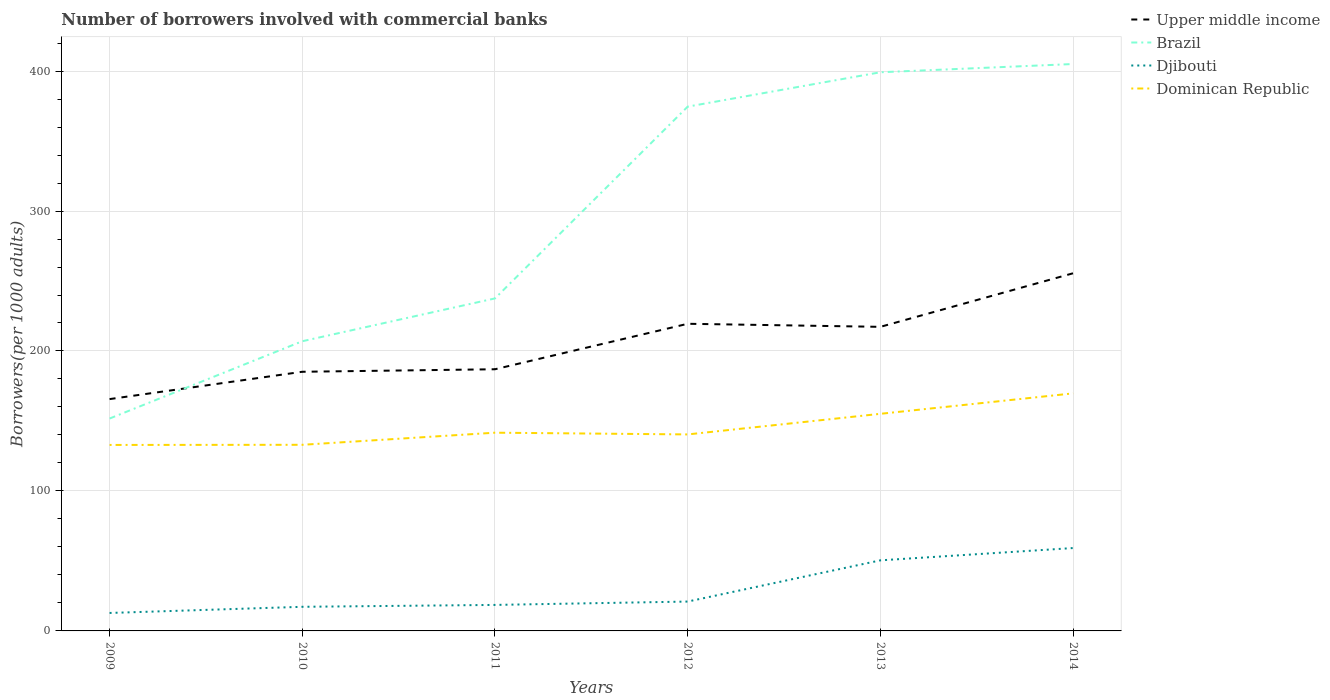How many different coloured lines are there?
Provide a succinct answer. 4. Does the line corresponding to Upper middle income intersect with the line corresponding to Dominican Republic?
Provide a succinct answer. No. Is the number of lines equal to the number of legend labels?
Offer a very short reply. Yes. Across all years, what is the maximum number of borrowers involved with commercial banks in Brazil?
Your answer should be compact. 151.74. What is the total number of borrowers involved with commercial banks in Djibouti in the graph?
Provide a short and direct response. -40.64. What is the difference between the highest and the second highest number of borrowers involved with commercial banks in Djibouti?
Provide a short and direct response. 46.39. What is the difference between the highest and the lowest number of borrowers involved with commercial banks in Djibouti?
Offer a very short reply. 2. Are the values on the major ticks of Y-axis written in scientific E-notation?
Your answer should be very brief. No. Does the graph contain any zero values?
Ensure brevity in your answer.  No. How many legend labels are there?
Ensure brevity in your answer.  4. How are the legend labels stacked?
Your answer should be compact. Vertical. What is the title of the graph?
Your response must be concise. Number of borrowers involved with commercial banks. Does "China" appear as one of the legend labels in the graph?
Provide a short and direct response. No. What is the label or title of the Y-axis?
Your answer should be compact. Borrowers(per 1000 adults). What is the Borrowers(per 1000 adults) of Upper middle income in 2009?
Make the answer very short. 165.63. What is the Borrowers(per 1000 adults) in Brazil in 2009?
Your answer should be very brief. 151.74. What is the Borrowers(per 1000 adults) in Djibouti in 2009?
Ensure brevity in your answer.  12.83. What is the Borrowers(per 1000 adults) of Dominican Republic in 2009?
Ensure brevity in your answer.  132.88. What is the Borrowers(per 1000 adults) of Upper middle income in 2010?
Provide a short and direct response. 185.15. What is the Borrowers(per 1000 adults) in Brazil in 2010?
Keep it short and to the point. 206.97. What is the Borrowers(per 1000 adults) in Djibouti in 2010?
Your answer should be very brief. 17.23. What is the Borrowers(per 1000 adults) in Dominican Republic in 2010?
Offer a very short reply. 132.98. What is the Borrowers(per 1000 adults) of Upper middle income in 2011?
Your answer should be compact. 186.95. What is the Borrowers(per 1000 adults) in Brazil in 2011?
Ensure brevity in your answer.  237.57. What is the Borrowers(per 1000 adults) in Djibouti in 2011?
Keep it short and to the point. 18.58. What is the Borrowers(per 1000 adults) of Dominican Republic in 2011?
Make the answer very short. 141.63. What is the Borrowers(per 1000 adults) of Upper middle income in 2012?
Your response must be concise. 219.44. What is the Borrowers(per 1000 adults) of Brazil in 2012?
Make the answer very short. 374.59. What is the Borrowers(per 1000 adults) of Djibouti in 2012?
Your answer should be compact. 20.98. What is the Borrowers(per 1000 adults) in Dominican Republic in 2012?
Your answer should be very brief. 140.39. What is the Borrowers(per 1000 adults) of Upper middle income in 2013?
Make the answer very short. 217.26. What is the Borrowers(per 1000 adults) in Brazil in 2013?
Offer a very short reply. 399.14. What is the Borrowers(per 1000 adults) of Djibouti in 2013?
Your answer should be compact. 50.43. What is the Borrowers(per 1000 adults) in Dominican Republic in 2013?
Ensure brevity in your answer.  155.11. What is the Borrowers(per 1000 adults) of Upper middle income in 2014?
Your response must be concise. 255.53. What is the Borrowers(per 1000 adults) in Brazil in 2014?
Make the answer very short. 405.03. What is the Borrowers(per 1000 adults) in Djibouti in 2014?
Your answer should be very brief. 59.22. What is the Borrowers(per 1000 adults) in Dominican Republic in 2014?
Offer a terse response. 169.72. Across all years, what is the maximum Borrowers(per 1000 adults) in Upper middle income?
Your answer should be very brief. 255.53. Across all years, what is the maximum Borrowers(per 1000 adults) of Brazil?
Your answer should be compact. 405.03. Across all years, what is the maximum Borrowers(per 1000 adults) of Djibouti?
Make the answer very short. 59.22. Across all years, what is the maximum Borrowers(per 1000 adults) in Dominican Republic?
Your response must be concise. 169.72. Across all years, what is the minimum Borrowers(per 1000 adults) of Upper middle income?
Offer a very short reply. 165.63. Across all years, what is the minimum Borrowers(per 1000 adults) in Brazil?
Offer a very short reply. 151.74. Across all years, what is the minimum Borrowers(per 1000 adults) of Djibouti?
Your answer should be compact. 12.83. Across all years, what is the minimum Borrowers(per 1000 adults) of Dominican Republic?
Provide a short and direct response. 132.88. What is the total Borrowers(per 1000 adults) in Upper middle income in the graph?
Make the answer very short. 1229.96. What is the total Borrowers(per 1000 adults) in Brazil in the graph?
Offer a terse response. 1775.05. What is the total Borrowers(per 1000 adults) in Djibouti in the graph?
Your response must be concise. 179.27. What is the total Borrowers(per 1000 adults) in Dominican Republic in the graph?
Make the answer very short. 872.71. What is the difference between the Borrowers(per 1000 adults) of Upper middle income in 2009 and that in 2010?
Provide a short and direct response. -19.53. What is the difference between the Borrowers(per 1000 adults) of Brazil in 2009 and that in 2010?
Your answer should be compact. -55.23. What is the difference between the Borrowers(per 1000 adults) of Djibouti in 2009 and that in 2010?
Keep it short and to the point. -4.4. What is the difference between the Borrowers(per 1000 adults) in Dominican Republic in 2009 and that in 2010?
Give a very brief answer. -0.1. What is the difference between the Borrowers(per 1000 adults) in Upper middle income in 2009 and that in 2011?
Ensure brevity in your answer.  -21.33. What is the difference between the Borrowers(per 1000 adults) in Brazil in 2009 and that in 2011?
Give a very brief answer. -85.83. What is the difference between the Borrowers(per 1000 adults) of Djibouti in 2009 and that in 2011?
Keep it short and to the point. -5.75. What is the difference between the Borrowers(per 1000 adults) of Dominican Republic in 2009 and that in 2011?
Provide a succinct answer. -8.75. What is the difference between the Borrowers(per 1000 adults) in Upper middle income in 2009 and that in 2012?
Keep it short and to the point. -53.81. What is the difference between the Borrowers(per 1000 adults) in Brazil in 2009 and that in 2012?
Provide a succinct answer. -222.85. What is the difference between the Borrowers(per 1000 adults) in Djibouti in 2009 and that in 2012?
Ensure brevity in your answer.  -8.15. What is the difference between the Borrowers(per 1000 adults) in Dominican Republic in 2009 and that in 2012?
Ensure brevity in your answer.  -7.51. What is the difference between the Borrowers(per 1000 adults) in Upper middle income in 2009 and that in 2013?
Provide a short and direct response. -51.63. What is the difference between the Borrowers(per 1000 adults) of Brazil in 2009 and that in 2013?
Offer a terse response. -247.4. What is the difference between the Borrowers(per 1000 adults) in Djibouti in 2009 and that in 2013?
Ensure brevity in your answer.  -37.59. What is the difference between the Borrowers(per 1000 adults) in Dominican Republic in 2009 and that in 2013?
Ensure brevity in your answer.  -22.24. What is the difference between the Borrowers(per 1000 adults) in Upper middle income in 2009 and that in 2014?
Your response must be concise. -89.9. What is the difference between the Borrowers(per 1000 adults) in Brazil in 2009 and that in 2014?
Ensure brevity in your answer.  -253.29. What is the difference between the Borrowers(per 1000 adults) of Djibouti in 2009 and that in 2014?
Your answer should be compact. -46.39. What is the difference between the Borrowers(per 1000 adults) of Dominican Republic in 2009 and that in 2014?
Your response must be concise. -36.85. What is the difference between the Borrowers(per 1000 adults) in Upper middle income in 2010 and that in 2011?
Keep it short and to the point. -1.8. What is the difference between the Borrowers(per 1000 adults) of Brazil in 2010 and that in 2011?
Ensure brevity in your answer.  -30.59. What is the difference between the Borrowers(per 1000 adults) of Djibouti in 2010 and that in 2011?
Your answer should be compact. -1.35. What is the difference between the Borrowers(per 1000 adults) of Dominican Republic in 2010 and that in 2011?
Provide a short and direct response. -8.65. What is the difference between the Borrowers(per 1000 adults) of Upper middle income in 2010 and that in 2012?
Provide a succinct answer. -34.28. What is the difference between the Borrowers(per 1000 adults) in Brazil in 2010 and that in 2012?
Provide a succinct answer. -167.62. What is the difference between the Borrowers(per 1000 adults) in Djibouti in 2010 and that in 2012?
Keep it short and to the point. -3.75. What is the difference between the Borrowers(per 1000 adults) of Dominican Republic in 2010 and that in 2012?
Provide a succinct answer. -7.41. What is the difference between the Borrowers(per 1000 adults) in Upper middle income in 2010 and that in 2013?
Your response must be concise. -32.1. What is the difference between the Borrowers(per 1000 adults) of Brazil in 2010 and that in 2013?
Keep it short and to the point. -192.17. What is the difference between the Borrowers(per 1000 adults) in Djibouti in 2010 and that in 2013?
Offer a very short reply. -33.19. What is the difference between the Borrowers(per 1000 adults) of Dominican Republic in 2010 and that in 2013?
Ensure brevity in your answer.  -22.14. What is the difference between the Borrowers(per 1000 adults) of Upper middle income in 2010 and that in 2014?
Keep it short and to the point. -70.38. What is the difference between the Borrowers(per 1000 adults) in Brazil in 2010 and that in 2014?
Ensure brevity in your answer.  -198.06. What is the difference between the Borrowers(per 1000 adults) in Djibouti in 2010 and that in 2014?
Keep it short and to the point. -41.99. What is the difference between the Borrowers(per 1000 adults) of Dominican Republic in 2010 and that in 2014?
Your response must be concise. -36.74. What is the difference between the Borrowers(per 1000 adults) of Upper middle income in 2011 and that in 2012?
Provide a succinct answer. -32.48. What is the difference between the Borrowers(per 1000 adults) of Brazil in 2011 and that in 2012?
Your answer should be very brief. -137.03. What is the difference between the Borrowers(per 1000 adults) of Djibouti in 2011 and that in 2012?
Ensure brevity in your answer.  -2.4. What is the difference between the Borrowers(per 1000 adults) of Dominican Republic in 2011 and that in 2012?
Your answer should be compact. 1.24. What is the difference between the Borrowers(per 1000 adults) in Upper middle income in 2011 and that in 2013?
Give a very brief answer. -30.3. What is the difference between the Borrowers(per 1000 adults) of Brazil in 2011 and that in 2013?
Ensure brevity in your answer.  -161.57. What is the difference between the Borrowers(per 1000 adults) of Djibouti in 2011 and that in 2013?
Provide a succinct answer. -31.85. What is the difference between the Borrowers(per 1000 adults) of Dominican Republic in 2011 and that in 2013?
Your answer should be very brief. -13.49. What is the difference between the Borrowers(per 1000 adults) of Upper middle income in 2011 and that in 2014?
Offer a terse response. -68.58. What is the difference between the Borrowers(per 1000 adults) in Brazil in 2011 and that in 2014?
Provide a short and direct response. -167.46. What is the difference between the Borrowers(per 1000 adults) of Djibouti in 2011 and that in 2014?
Give a very brief answer. -40.64. What is the difference between the Borrowers(per 1000 adults) in Dominican Republic in 2011 and that in 2014?
Provide a short and direct response. -28.09. What is the difference between the Borrowers(per 1000 adults) of Upper middle income in 2012 and that in 2013?
Provide a short and direct response. 2.18. What is the difference between the Borrowers(per 1000 adults) of Brazil in 2012 and that in 2013?
Keep it short and to the point. -24.55. What is the difference between the Borrowers(per 1000 adults) of Djibouti in 2012 and that in 2013?
Give a very brief answer. -29.45. What is the difference between the Borrowers(per 1000 adults) of Dominican Republic in 2012 and that in 2013?
Offer a terse response. -14.72. What is the difference between the Borrowers(per 1000 adults) of Upper middle income in 2012 and that in 2014?
Offer a very short reply. -36.09. What is the difference between the Borrowers(per 1000 adults) in Brazil in 2012 and that in 2014?
Offer a terse response. -30.44. What is the difference between the Borrowers(per 1000 adults) of Djibouti in 2012 and that in 2014?
Offer a very short reply. -38.24. What is the difference between the Borrowers(per 1000 adults) of Dominican Republic in 2012 and that in 2014?
Your answer should be very brief. -29.33. What is the difference between the Borrowers(per 1000 adults) of Upper middle income in 2013 and that in 2014?
Keep it short and to the point. -38.28. What is the difference between the Borrowers(per 1000 adults) in Brazil in 2013 and that in 2014?
Offer a terse response. -5.89. What is the difference between the Borrowers(per 1000 adults) of Djibouti in 2013 and that in 2014?
Keep it short and to the point. -8.79. What is the difference between the Borrowers(per 1000 adults) in Dominican Republic in 2013 and that in 2014?
Your answer should be very brief. -14.61. What is the difference between the Borrowers(per 1000 adults) in Upper middle income in 2009 and the Borrowers(per 1000 adults) in Brazil in 2010?
Offer a very short reply. -41.35. What is the difference between the Borrowers(per 1000 adults) of Upper middle income in 2009 and the Borrowers(per 1000 adults) of Djibouti in 2010?
Provide a succinct answer. 148.39. What is the difference between the Borrowers(per 1000 adults) in Upper middle income in 2009 and the Borrowers(per 1000 adults) in Dominican Republic in 2010?
Offer a very short reply. 32.65. What is the difference between the Borrowers(per 1000 adults) in Brazil in 2009 and the Borrowers(per 1000 adults) in Djibouti in 2010?
Keep it short and to the point. 134.51. What is the difference between the Borrowers(per 1000 adults) in Brazil in 2009 and the Borrowers(per 1000 adults) in Dominican Republic in 2010?
Give a very brief answer. 18.76. What is the difference between the Borrowers(per 1000 adults) in Djibouti in 2009 and the Borrowers(per 1000 adults) in Dominican Republic in 2010?
Your answer should be compact. -120.15. What is the difference between the Borrowers(per 1000 adults) in Upper middle income in 2009 and the Borrowers(per 1000 adults) in Brazil in 2011?
Provide a succinct answer. -71.94. What is the difference between the Borrowers(per 1000 adults) in Upper middle income in 2009 and the Borrowers(per 1000 adults) in Djibouti in 2011?
Make the answer very short. 147.05. What is the difference between the Borrowers(per 1000 adults) in Upper middle income in 2009 and the Borrowers(per 1000 adults) in Dominican Republic in 2011?
Ensure brevity in your answer.  24. What is the difference between the Borrowers(per 1000 adults) of Brazil in 2009 and the Borrowers(per 1000 adults) of Djibouti in 2011?
Your answer should be compact. 133.16. What is the difference between the Borrowers(per 1000 adults) in Brazil in 2009 and the Borrowers(per 1000 adults) in Dominican Republic in 2011?
Your response must be concise. 10.11. What is the difference between the Borrowers(per 1000 adults) of Djibouti in 2009 and the Borrowers(per 1000 adults) of Dominican Republic in 2011?
Make the answer very short. -128.8. What is the difference between the Borrowers(per 1000 adults) of Upper middle income in 2009 and the Borrowers(per 1000 adults) of Brazil in 2012?
Your answer should be very brief. -208.97. What is the difference between the Borrowers(per 1000 adults) in Upper middle income in 2009 and the Borrowers(per 1000 adults) in Djibouti in 2012?
Your answer should be compact. 144.65. What is the difference between the Borrowers(per 1000 adults) in Upper middle income in 2009 and the Borrowers(per 1000 adults) in Dominican Republic in 2012?
Provide a short and direct response. 25.24. What is the difference between the Borrowers(per 1000 adults) of Brazil in 2009 and the Borrowers(per 1000 adults) of Djibouti in 2012?
Your response must be concise. 130.76. What is the difference between the Borrowers(per 1000 adults) of Brazil in 2009 and the Borrowers(per 1000 adults) of Dominican Republic in 2012?
Ensure brevity in your answer.  11.35. What is the difference between the Borrowers(per 1000 adults) in Djibouti in 2009 and the Borrowers(per 1000 adults) in Dominican Republic in 2012?
Your answer should be very brief. -127.56. What is the difference between the Borrowers(per 1000 adults) in Upper middle income in 2009 and the Borrowers(per 1000 adults) in Brazil in 2013?
Your answer should be compact. -233.52. What is the difference between the Borrowers(per 1000 adults) of Upper middle income in 2009 and the Borrowers(per 1000 adults) of Djibouti in 2013?
Provide a short and direct response. 115.2. What is the difference between the Borrowers(per 1000 adults) in Upper middle income in 2009 and the Borrowers(per 1000 adults) in Dominican Republic in 2013?
Your answer should be compact. 10.51. What is the difference between the Borrowers(per 1000 adults) in Brazil in 2009 and the Borrowers(per 1000 adults) in Djibouti in 2013?
Your answer should be compact. 101.31. What is the difference between the Borrowers(per 1000 adults) in Brazil in 2009 and the Borrowers(per 1000 adults) in Dominican Republic in 2013?
Offer a terse response. -3.37. What is the difference between the Borrowers(per 1000 adults) in Djibouti in 2009 and the Borrowers(per 1000 adults) in Dominican Republic in 2013?
Your response must be concise. -142.28. What is the difference between the Borrowers(per 1000 adults) in Upper middle income in 2009 and the Borrowers(per 1000 adults) in Brazil in 2014?
Offer a very short reply. -239.4. What is the difference between the Borrowers(per 1000 adults) in Upper middle income in 2009 and the Borrowers(per 1000 adults) in Djibouti in 2014?
Make the answer very short. 106.41. What is the difference between the Borrowers(per 1000 adults) of Upper middle income in 2009 and the Borrowers(per 1000 adults) of Dominican Republic in 2014?
Your answer should be compact. -4.09. What is the difference between the Borrowers(per 1000 adults) of Brazil in 2009 and the Borrowers(per 1000 adults) of Djibouti in 2014?
Provide a succinct answer. 92.52. What is the difference between the Borrowers(per 1000 adults) of Brazil in 2009 and the Borrowers(per 1000 adults) of Dominican Republic in 2014?
Your response must be concise. -17.98. What is the difference between the Borrowers(per 1000 adults) of Djibouti in 2009 and the Borrowers(per 1000 adults) of Dominican Republic in 2014?
Give a very brief answer. -156.89. What is the difference between the Borrowers(per 1000 adults) in Upper middle income in 2010 and the Borrowers(per 1000 adults) in Brazil in 2011?
Make the answer very short. -52.42. What is the difference between the Borrowers(per 1000 adults) in Upper middle income in 2010 and the Borrowers(per 1000 adults) in Djibouti in 2011?
Offer a terse response. 166.57. What is the difference between the Borrowers(per 1000 adults) of Upper middle income in 2010 and the Borrowers(per 1000 adults) of Dominican Republic in 2011?
Make the answer very short. 43.52. What is the difference between the Borrowers(per 1000 adults) of Brazil in 2010 and the Borrowers(per 1000 adults) of Djibouti in 2011?
Your answer should be compact. 188.39. What is the difference between the Borrowers(per 1000 adults) in Brazil in 2010 and the Borrowers(per 1000 adults) in Dominican Republic in 2011?
Offer a terse response. 65.35. What is the difference between the Borrowers(per 1000 adults) of Djibouti in 2010 and the Borrowers(per 1000 adults) of Dominican Republic in 2011?
Give a very brief answer. -124.4. What is the difference between the Borrowers(per 1000 adults) of Upper middle income in 2010 and the Borrowers(per 1000 adults) of Brazil in 2012?
Offer a terse response. -189.44. What is the difference between the Borrowers(per 1000 adults) in Upper middle income in 2010 and the Borrowers(per 1000 adults) in Djibouti in 2012?
Ensure brevity in your answer.  164.17. What is the difference between the Borrowers(per 1000 adults) of Upper middle income in 2010 and the Borrowers(per 1000 adults) of Dominican Republic in 2012?
Ensure brevity in your answer.  44.76. What is the difference between the Borrowers(per 1000 adults) of Brazil in 2010 and the Borrowers(per 1000 adults) of Djibouti in 2012?
Offer a terse response. 186. What is the difference between the Borrowers(per 1000 adults) in Brazil in 2010 and the Borrowers(per 1000 adults) in Dominican Republic in 2012?
Offer a terse response. 66.58. What is the difference between the Borrowers(per 1000 adults) of Djibouti in 2010 and the Borrowers(per 1000 adults) of Dominican Republic in 2012?
Give a very brief answer. -123.16. What is the difference between the Borrowers(per 1000 adults) of Upper middle income in 2010 and the Borrowers(per 1000 adults) of Brazil in 2013?
Ensure brevity in your answer.  -213.99. What is the difference between the Borrowers(per 1000 adults) of Upper middle income in 2010 and the Borrowers(per 1000 adults) of Djibouti in 2013?
Give a very brief answer. 134.73. What is the difference between the Borrowers(per 1000 adults) of Upper middle income in 2010 and the Borrowers(per 1000 adults) of Dominican Republic in 2013?
Provide a succinct answer. 30.04. What is the difference between the Borrowers(per 1000 adults) of Brazil in 2010 and the Borrowers(per 1000 adults) of Djibouti in 2013?
Provide a short and direct response. 156.55. What is the difference between the Borrowers(per 1000 adults) in Brazil in 2010 and the Borrowers(per 1000 adults) in Dominican Republic in 2013?
Ensure brevity in your answer.  51.86. What is the difference between the Borrowers(per 1000 adults) in Djibouti in 2010 and the Borrowers(per 1000 adults) in Dominican Republic in 2013?
Your response must be concise. -137.88. What is the difference between the Borrowers(per 1000 adults) in Upper middle income in 2010 and the Borrowers(per 1000 adults) in Brazil in 2014?
Your answer should be very brief. -219.88. What is the difference between the Borrowers(per 1000 adults) in Upper middle income in 2010 and the Borrowers(per 1000 adults) in Djibouti in 2014?
Offer a very short reply. 125.93. What is the difference between the Borrowers(per 1000 adults) in Upper middle income in 2010 and the Borrowers(per 1000 adults) in Dominican Republic in 2014?
Offer a terse response. 15.43. What is the difference between the Borrowers(per 1000 adults) in Brazil in 2010 and the Borrowers(per 1000 adults) in Djibouti in 2014?
Your response must be concise. 147.75. What is the difference between the Borrowers(per 1000 adults) in Brazil in 2010 and the Borrowers(per 1000 adults) in Dominican Republic in 2014?
Keep it short and to the point. 37.25. What is the difference between the Borrowers(per 1000 adults) in Djibouti in 2010 and the Borrowers(per 1000 adults) in Dominican Republic in 2014?
Ensure brevity in your answer.  -152.49. What is the difference between the Borrowers(per 1000 adults) of Upper middle income in 2011 and the Borrowers(per 1000 adults) of Brazil in 2012?
Your answer should be compact. -187.64. What is the difference between the Borrowers(per 1000 adults) in Upper middle income in 2011 and the Borrowers(per 1000 adults) in Djibouti in 2012?
Provide a succinct answer. 165.98. What is the difference between the Borrowers(per 1000 adults) in Upper middle income in 2011 and the Borrowers(per 1000 adults) in Dominican Republic in 2012?
Offer a terse response. 46.56. What is the difference between the Borrowers(per 1000 adults) of Brazil in 2011 and the Borrowers(per 1000 adults) of Djibouti in 2012?
Give a very brief answer. 216.59. What is the difference between the Borrowers(per 1000 adults) of Brazil in 2011 and the Borrowers(per 1000 adults) of Dominican Republic in 2012?
Offer a terse response. 97.18. What is the difference between the Borrowers(per 1000 adults) in Djibouti in 2011 and the Borrowers(per 1000 adults) in Dominican Republic in 2012?
Ensure brevity in your answer.  -121.81. What is the difference between the Borrowers(per 1000 adults) of Upper middle income in 2011 and the Borrowers(per 1000 adults) of Brazil in 2013?
Offer a terse response. -212.19. What is the difference between the Borrowers(per 1000 adults) in Upper middle income in 2011 and the Borrowers(per 1000 adults) in Djibouti in 2013?
Offer a terse response. 136.53. What is the difference between the Borrowers(per 1000 adults) of Upper middle income in 2011 and the Borrowers(per 1000 adults) of Dominican Republic in 2013?
Offer a terse response. 31.84. What is the difference between the Borrowers(per 1000 adults) in Brazil in 2011 and the Borrowers(per 1000 adults) in Djibouti in 2013?
Provide a succinct answer. 187.14. What is the difference between the Borrowers(per 1000 adults) in Brazil in 2011 and the Borrowers(per 1000 adults) in Dominican Republic in 2013?
Provide a short and direct response. 82.45. What is the difference between the Borrowers(per 1000 adults) of Djibouti in 2011 and the Borrowers(per 1000 adults) of Dominican Republic in 2013?
Your response must be concise. -136.53. What is the difference between the Borrowers(per 1000 adults) in Upper middle income in 2011 and the Borrowers(per 1000 adults) in Brazil in 2014?
Your response must be concise. -218.08. What is the difference between the Borrowers(per 1000 adults) of Upper middle income in 2011 and the Borrowers(per 1000 adults) of Djibouti in 2014?
Ensure brevity in your answer.  127.73. What is the difference between the Borrowers(per 1000 adults) in Upper middle income in 2011 and the Borrowers(per 1000 adults) in Dominican Republic in 2014?
Make the answer very short. 17.23. What is the difference between the Borrowers(per 1000 adults) in Brazil in 2011 and the Borrowers(per 1000 adults) in Djibouti in 2014?
Your answer should be very brief. 178.35. What is the difference between the Borrowers(per 1000 adults) of Brazil in 2011 and the Borrowers(per 1000 adults) of Dominican Republic in 2014?
Provide a succinct answer. 67.85. What is the difference between the Borrowers(per 1000 adults) in Djibouti in 2011 and the Borrowers(per 1000 adults) in Dominican Republic in 2014?
Offer a terse response. -151.14. What is the difference between the Borrowers(per 1000 adults) in Upper middle income in 2012 and the Borrowers(per 1000 adults) in Brazil in 2013?
Provide a succinct answer. -179.71. What is the difference between the Borrowers(per 1000 adults) of Upper middle income in 2012 and the Borrowers(per 1000 adults) of Djibouti in 2013?
Your answer should be compact. 169.01. What is the difference between the Borrowers(per 1000 adults) in Upper middle income in 2012 and the Borrowers(per 1000 adults) in Dominican Republic in 2013?
Make the answer very short. 64.32. What is the difference between the Borrowers(per 1000 adults) in Brazil in 2012 and the Borrowers(per 1000 adults) in Djibouti in 2013?
Your response must be concise. 324.17. What is the difference between the Borrowers(per 1000 adults) in Brazil in 2012 and the Borrowers(per 1000 adults) in Dominican Republic in 2013?
Make the answer very short. 219.48. What is the difference between the Borrowers(per 1000 adults) of Djibouti in 2012 and the Borrowers(per 1000 adults) of Dominican Republic in 2013?
Give a very brief answer. -134.13. What is the difference between the Borrowers(per 1000 adults) in Upper middle income in 2012 and the Borrowers(per 1000 adults) in Brazil in 2014?
Your response must be concise. -185.59. What is the difference between the Borrowers(per 1000 adults) of Upper middle income in 2012 and the Borrowers(per 1000 adults) of Djibouti in 2014?
Give a very brief answer. 160.22. What is the difference between the Borrowers(per 1000 adults) in Upper middle income in 2012 and the Borrowers(per 1000 adults) in Dominican Republic in 2014?
Give a very brief answer. 49.72. What is the difference between the Borrowers(per 1000 adults) in Brazil in 2012 and the Borrowers(per 1000 adults) in Djibouti in 2014?
Offer a very short reply. 315.37. What is the difference between the Borrowers(per 1000 adults) in Brazil in 2012 and the Borrowers(per 1000 adults) in Dominican Republic in 2014?
Your answer should be very brief. 204.87. What is the difference between the Borrowers(per 1000 adults) of Djibouti in 2012 and the Borrowers(per 1000 adults) of Dominican Republic in 2014?
Offer a very short reply. -148.74. What is the difference between the Borrowers(per 1000 adults) of Upper middle income in 2013 and the Borrowers(per 1000 adults) of Brazil in 2014?
Offer a very short reply. -187.77. What is the difference between the Borrowers(per 1000 adults) in Upper middle income in 2013 and the Borrowers(per 1000 adults) in Djibouti in 2014?
Keep it short and to the point. 158.04. What is the difference between the Borrowers(per 1000 adults) of Upper middle income in 2013 and the Borrowers(per 1000 adults) of Dominican Republic in 2014?
Make the answer very short. 47.53. What is the difference between the Borrowers(per 1000 adults) in Brazil in 2013 and the Borrowers(per 1000 adults) in Djibouti in 2014?
Provide a succinct answer. 339.92. What is the difference between the Borrowers(per 1000 adults) in Brazil in 2013 and the Borrowers(per 1000 adults) in Dominican Republic in 2014?
Provide a short and direct response. 229.42. What is the difference between the Borrowers(per 1000 adults) in Djibouti in 2013 and the Borrowers(per 1000 adults) in Dominican Republic in 2014?
Provide a short and direct response. -119.29. What is the average Borrowers(per 1000 adults) in Upper middle income per year?
Your answer should be compact. 204.99. What is the average Borrowers(per 1000 adults) in Brazil per year?
Offer a terse response. 295.84. What is the average Borrowers(per 1000 adults) of Djibouti per year?
Give a very brief answer. 29.88. What is the average Borrowers(per 1000 adults) of Dominican Republic per year?
Offer a terse response. 145.45. In the year 2009, what is the difference between the Borrowers(per 1000 adults) of Upper middle income and Borrowers(per 1000 adults) of Brazil?
Ensure brevity in your answer.  13.89. In the year 2009, what is the difference between the Borrowers(per 1000 adults) in Upper middle income and Borrowers(per 1000 adults) in Djibouti?
Keep it short and to the point. 152.8. In the year 2009, what is the difference between the Borrowers(per 1000 adults) in Upper middle income and Borrowers(per 1000 adults) in Dominican Republic?
Give a very brief answer. 32.75. In the year 2009, what is the difference between the Borrowers(per 1000 adults) of Brazil and Borrowers(per 1000 adults) of Djibouti?
Offer a terse response. 138.91. In the year 2009, what is the difference between the Borrowers(per 1000 adults) of Brazil and Borrowers(per 1000 adults) of Dominican Republic?
Keep it short and to the point. 18.86. In the year 2009, what is the difference between the Borrowers(per 1000 adults) of Djibouti and Borrowers(per 1000 adults) of Dominican Republic?
Offer a very short reply. -120.04. In the year 2010, what is the difference between the Borrowers(per 1000 adults) of Upper middle income and Borrowers(per 1000 adults) of Brazil?
Your answer should be compact. -21.82. In the year 2010, what is the difference between the Borrowers(per 1000 adults) of Upper middle income and Borrowers(per 1000 adults) of Djibouti?
Keep it short and to the point. 167.92. In the year 2010, what is the difference between the Borrowers(per 1000 adults) in Upper middle income and Borrowers(per 1000 adults) in Dominican Republic?
Ensure brevity in your answer.  52.17. In the year 2010, what is the difference between the Borrowers(per 1000 adults) of Brazil and Borrowers(per 1000 adults) of Djibouti?
Make the answer very short. 189.74. In the year 2010, what is the difference between the Borrowers(per 1000 adults) in Brazil and Borrowers(per 1000 adults) in Dominican Republic?
Your answer should be compact. 74. In the year 2010, what is the difference between the Borrowers(per 1000 adults) of Djibouti and Borrowers(per 1000 adults) of Dominican Republic?
Give a very brief answer. -115.75. In the year 2011, what is the difference between the Borrowers(per 1000 adults) in Upper middle income and Borrowers(per 1000 adults) in Brazil?
Your response must be concise. -50.61. In the year 2011, what is the difference between the Borrowers(per 1000 adults) in Upper middle income and Borrowers(per 1000 adults) in Djibouti?
Offer a very short reply. 168.38. In the year 2011, what is the difference between the Borrowers(per 1000 adults) in Upper middle income and Borrowers(per 1000 adults) in Dominican Republic?
Offer a terse response. 45.33. In the year 2011, what is the difference between the Borrowers(per 1000 adults) of Brazil and Borrowers(per 1000 adults) of Djibouti?
Your answer should be very brief. 218.99. In the year 2011, what is the difference between the Borrowers(per 1000 adults) of Brazil and Borrowers(per 1000 adults) of Dominican Republic?
Your answer should be very brief. 95.94. In the year 2011, what is the difference between the Borrowers(per 1000 adults) of Djibouti and Borrowers(per 1000 adults) of Dominican Republic?
Ensure brevity in your answer.  -123.05. In the year 2012, what is the difference between the Borrowers(per 1000 adults) in Upper middle income and Borrowers(per 1000 adults) in Brazil?
Offer a terse response. -155.16. In the year 2012, what is the difference between the Borrowers(per 1000 adults) of Upper middle income and Borrowers(per 1000 adults) of Djibouti?
Your answer should be compact. 198.46. In the year 2012, what is the difference between the Borrowers(per 1000 adults) of Upper middle income and Borrowers(per 1000 adults) of Dominican Republic?
Your answer should be very brief. 79.05. In the year 2012, what is the difference between the Borrowers(per 1000 adults) of Brazil and Borrowers(per 1000 adults) of Djibouti?
Ensure brevity in your answer.  353.62. In the year 2012, what is the difference between the Borrowers(per 1000 adults) of Brazil and Borrowers(per 1000 adults) of Dominican Republic?
Make the answer very short. 234.2. In the year 2012, what is the difference between the Borrowers(per 1000 adults) of Djibouti and Borrowers(per 1000 adults) of Dominican Republic?
Your answer should be very brief. -119.41. In the year 2013, what is the difference between the Borrowers(per 1000 adults) in Upper middle income and Borrowers(per 1000 adults) in Brazil?
Offer a terse response. -181.89. In the year 2013, what is the difference between the Borrowers(per 1000 adults) of Upper middle income and Borrowers(per 1000 adults) of Djibouti?
Offer a terse response. 166.83. In the year 2013, what is the difference between the Borrowers(per 1000 adults) of Upper middle income and Borrowers(per 1000 adults) of Dominican Republic?
Provide a succinct answer. 62.14. In the year 2013, what is the difference between the Borrowers(per 1000 adults) in Brazil and Borrowers(per 1000 adults) in Djibouti?
Keep it short and to the point. 348.72. In the year 2013, what is the difference between the Borrowers(per 1000 adults) in Brazil and Borrowers(per 1000 adults) in Dominican Republic?
Give a very brief answer. 244.03. In the year 2013, what is the difference between the Borrowers(per 1000 adults) of Djibouti and Borrowers(per 1000 adults) of Dominican Republic?
Ensure brevity in your answer.  -104.69. In the year 2014, what is the difference between the Borrowers(per 1000 adults) in Upper middle income and Borrowers(per 1000 adults) in Brazil?
Ensure brevity in your answer.  -149.5. In the year 2014, what is the difference between the Borrowers(per 1000 adults) in Upper middle income and Borrowers(per 1000 adults) in Djibouti?
Provide a succinct answer. 196.31. In the year 2014, what is the difference between the Borrowers(per 1000 adults) in Upper middle income and Borrowers(per 1000 adults) in Dominican Republic?
Give a very brief answer. 85.81. In the year 2014, what is the difference between the Borrowers(per 1000 adults) of Brazil and Borrowers(per 1000 adults) of Djibouti?
Offer a terse response. 345.81. In the year 2014, what is the difference between the Borrowers(per 1000 adults) in Brazil and Borrowers(per 1000 adults) in Dominican Republic?
Provide a succinct answer. 235.31. In the year 2014, what is the difference between the Borrowers(per 1000 adults) in Djibouti and Borrowers(per 1000 adults) in Dominican Republic?
Ensure brevity in your answer.  -110.5. What is the ratio of the Borrowers(per 1000 adults) of Upper middle income in 2009 to that in 2010?
Give a very brief answer. 0.89. What is the ratio of the Borrowers(per 1000 adults) in Brazil in 2009 to that in 2010?
Your response must be concise. 0.73. What is the ratio of the Borrowers(per 1000 adults) in Djibouti in 2009 to that in 2010?
Your answer should be very brief. 0.74. What is the ratio of the Borrowers(per 1000 adults) in Upper middle income in 2009 to that in 2011?
Give a very brief answer. 0.89. What is the ratio of the Borrowers(per 1000 adults) in Brazil in 2009 to that in 2011?
Ensure brevity in your answer.  0.64. What is the ratio of the Borrowers(per 1000 adults) of Djibouti in 2009 to that in 2011?
Your answer should be very brief. 0.69. What is the ratio of the Borrowers(per 1000 adults) of Dominican Republic in 2009 to that in 2011?
Keep it short and to the point. 0.94. What is the ratio of the Borrowers(per 1000 adults) of Upper middle income in 2009 to that in 2012?
Make the answer very short. 0.75. What is the ratio of the Borrowers(per 1000 adults) of Brazil in 2009 to that in 2012?
Provide a short and direct response. 0.41. What is the ratio of the Borrowers(per 1000 adults) of Djibouti in 2009 to that in 2012?
Ensure brevity in your answer.  0.61. What is the ratio of the Borrowers(per 1000 adults) in Dominican Republic in 2009 to that in 2012?
Give a very brief answer. 0.95. What is the ratio of the Borrowers(per 1000 adults) of Upper middle income in 2009 to that in 2013?
Provide a short and direct response. 0.76. What is the ratio of the Borrowers(per 1000 adults) of Brazil in 2009 to that in 2013?
Offer a terse response. 0.38. What is the ratio of the Borrowers(per 1000 adults) in Djibouti in 2009 to that in 2013?
Keep it short and to the point. 0.25. What is the ratio of the Borrowers(per 1000 adults) in Dominican Republic in 2009 to that in 2013?
Your response must be concise. 0.86. What is the ratio of the Borrowers(per 1000 adults) of Upper middle income in 2009 to that in 2014?
Your answer should be compact. 0.65. What is the ratio of the Borrowers(per 1000 adults) of Brazil in 2009 to that in 2014?
Provide a succinct answer. 0.37. What is the ratio of the Borrowers(per 1000 adults) of Djibouti in 2009 to that in 2014?
Give a very brief answer. 0.22. What is the ratio of the Borrowers(per 1000 adults) in Dominican Republic in 2009 to that in 2014?
Your response must be concise. 0.78. What is the ratio of the Borrowers(per 1000 adults) of Brazil in 2010 to that in 2011?
Keep it short and to the point. 0.87. What is the ratio of the Borrowers(per 1000 adults) in Djibouti in 2010 to that in 2011?
Provide a short and direct response. 0.93. What is the ratio of the Borrowers(per 1000 adults) in Dominican Republic in 2010 to that in 2011?
Make the answer very short. 0.94. What is the ratio of the Borrowers(per 1000 adults) of Upper middle income in 2010 to that in 2012?
Give a very brief answer. 0.84. What is the ratio of the Borrowers(per 1000 adults) in Brazil in 2010 to that in 2012?
Offer a terse response. 0.55. What is the ratio of the Borrowers(per 1000 adults) of Djibouti in 2010 to that in 2012?
Your response must be concise. 0.82. What is the ratio of the Borrowers(per 1000 adults) in Dominican Republic in 2010 to that in 2012?
Offer a terse response. 0.95. What is the ratio of the Borrowers(per 1000 adults) in Upper middle income in 2010 to that in 2013?
Your answer should be very brief. 0.85. What is the ratio of the Borrowers(per 1000 adults) in Brazil in 2010 to that in 2013?
Offer a very short reply. 0.52. What is the ratio of the Borrowers(per 1000 adults) in Djibouti in 2010 to that in 2013?
Your answer should be compact. 0.34. What is the ratio of the Borrowers(per 1000 adults) in Dominican Republic in 2010 to that in 2013?
Provide a short and direct response. 0.86. What is the ratio of the Borrowers(per 1000 adults) of Upper middle income in 2010 to that in 2014?
Your answer should be very brief. 0.72. What is the ratio of the Borrowers(per 1000 adults) of Brazil in 2010 to that in 2014?
Provide a succinct answer. 0.51. What is the ratio of the Borrowers(per 1000 adults) of Djibouti in 2010 to that in 2014?
Offer a very short reply. 0.29. What is the ratio of the Borrowers(per 1000 adults) of Dominican Republic in 2010 to that in 2014?
Provide a short and direct response. 0.78. What is the ratio of the Borrowers(per 1000 adults) of Upper middle income in 2011 to that in 2012?
Offer a terse response. 0.85. What is the ratio of the Borrowers(per 1000 adults) in Brazil in 2011 to that in 2012?
Make the answer very short. 0.63. What is the ratio of the Borrowers(per 1000 adults) of Djibouti in 2011 to that in 2012?
Ensure brevity in your answer.  0.89. What is the ratio of the Borrowers(per 1000 adults) of Dominican Republic in 2011 to that in 2012?
Your answer should be compact. 1.01. What is the ratio of the Borrowers(per 1000 adults) in Upper middle income in 2011 to that in 2013?
Give a very brief answer. 0.86. What is the ratio of the Borrowers(per 1000 adults) of Brazil in 2011 to that in 2013?
Provide a succinct answer. 0.6. What is the ratio of the Borrowers(per 1000 adults) in Djibouti in 2011 to that in 2013?
Give a very brief answer. 0.37. What is the ratio of the Borrowers(per 1000 adults) in Dominican Republic in 2011 to that in 2013?
Give a very brief answer. 0.91. What is the ratio of the Borrowers(per 1000 adults) of Upper middle income in 2011 to that in 2014?
Your answer should be compact. 0.73. What is the ratio of the Borrowers(per 1000 adults) in Brazil in 2011 to that in 2014?
Give a very brief answer. 0.59. What is the ratio of the Borrowers(per 1000 adults) of Djibouti in 2011 to that in 2014?
Ensure brevity in your answer.  0.31. What is the ratio of the Borrowers(per 1000 adults) of Dominican Republic in 2011 to that in 2014?
Provide a succinct answer. 0.83. What is the ratio of the Borrowers(per 1000 adults) of Brazil in 2012 to that in 2013?
Give a very brief answer. 0.94. What is the ratio of the Borrowers(per 1000 adults) of Djibouti in 2012 to that in 2013?
Provide a short and direct response. 0.42. What is the ratio of the Borrowers(per 1000 adults) of Dominican Republic in 2012 to that in 2013?
Keep it short and to the point. 0.91. What is the ratio of the Borrowers(per 1000 adults) in Upper middle income in 2012 to that in 2014?
Ensure brevity in your answer.  0.86. What is the ratio of the Borrowers(per 1000 adults) in Brazil in 2012 to that in 2014?
Your answer should be compact. 0.92. What is the ratio of the Borrowers(per 1000 adults) of Djibouti in 2012 to that in 2014?
Offer a very short reply. 0.35. What is the ratio of the Borrowers(per 1000 adults) of Dominican Republic in 2012 to that in 2014?
Offer a very short reply. 0.83. What is the ratio of the Borrowers(per 1000 adults) in Upper middle income in 2013 to that in 2014?
Ensure brevity in your answer.  0.85. What is the ratio of the Borrowers(per 1000 adults) of Brazil in 2013 to that in 2014?
Your response must be concise. 0.99. What is the ratio of the Borrowers(per 1000 adults) in Djibouti in 2013 to that in 2014?
Offer a very short reply. 0.85. What is the ratio of the Borrowers(per 1000 adults) in Dominican Republic in 2013 to that in 2014?
Provide a short and direct response. 0.91. What is the difference between the highest and the second highest Borrowers(per 1000 adults) in Upper middle income?
Ensure brevity in your answer.  36.09. What is the difference between the highest and the second highest Borrowers(per 1000 adults) of Brazil?
Your response must be concise. 5.89. What is the difference between the highest and the second highest Borrowers(per 1000 adults) of Djibouti?
Your answer should be very brief. 8.79. What is the difference between the highest and the second highest Borrowers(per 1000 adults) in Dominican Republic?
Offer a very short reply. 14.61. What is the difference between the highest and the lowest Borrowers(per 1000 adults) of Upper middle income?
Give a very brief answer. 89.9. What is the difference between the highest and the lowest Borrowers(per 1000 adults) of Brazil?
Your answer should be compact. 253.29. What is the difference between the highest and the lowest Borrowers(per 1000 adults) in Djibouti?
Offer a very short reply. 46.39. What is the difference between the highest and the lowest Borrowers(per 1000 adults) of Dominican Republic?
Provide a short and direct response. 36.85. 